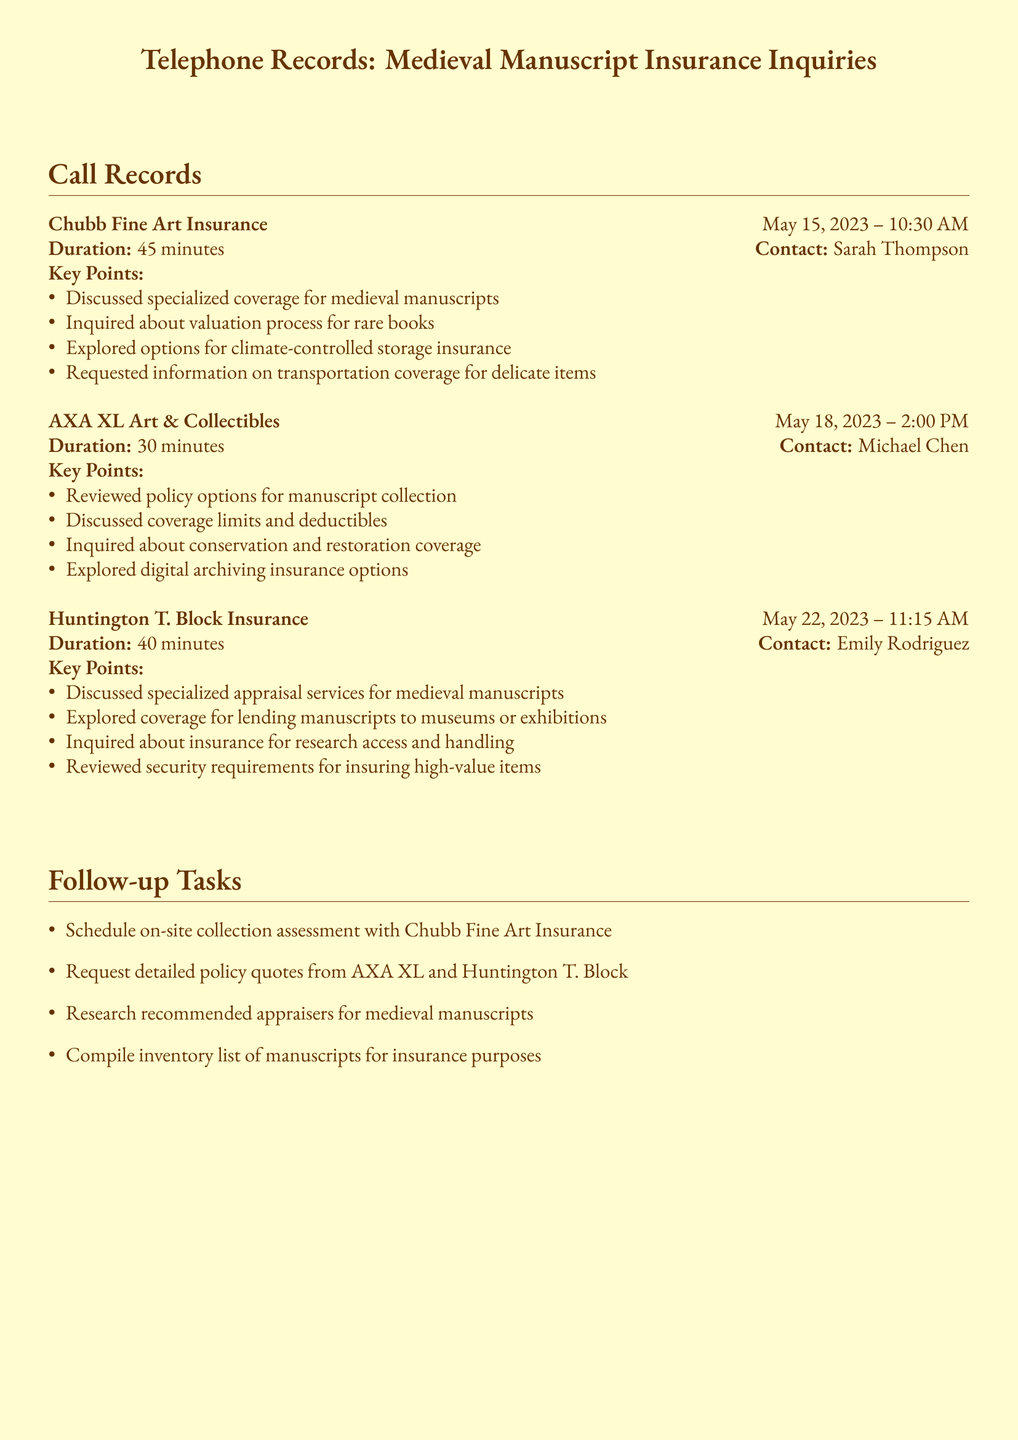What is the date of the call with Chubb Fine Art Insurance? The call with Chubb Fine Art Insurance occurred on May 15, 2023.
Answer: May 15, 2023 Who was the contact person for the call with AXA XL Art & Collectibles? The contact person for the call with AXA XL Art & Collectibles was Michael Chen.
Answer: Michael Chen How long was the call with Huntington T. Block Insurance? The duration of the call with Huntington T. Block Insurance was 40 minutes.
Answer: 40 minutes What key point was discussed regarding lending manuscripts? Coverage for lending manuscripts to museums or exhibitions was discussed.
Answer: Lending coverage What is one follow-up task listed after the calls? One follow-up task is to schedule an on-site collection assessment with Chubb Fine Art Insurance.
Answer: Schedule on-site collection assessment What insurance aspect did Sarah Thompson inquire about? Sarah Thompson inquired about the valuation process for rare books.
Answer: Valuation process Which insurance provider discussed digital archiving? AXA XL Art & Collectibles discussed digital archiving insurance options.
Answer: AXA XL Art & Collectibles What type of insurance was explored concerning climate control? Options for climate-controlled storage insurance were explored.
Answer: Climate-controlled storage insurance 